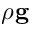<formula> <loc_0><loc_0><loc_500><loc_500>\rho g</formula> 